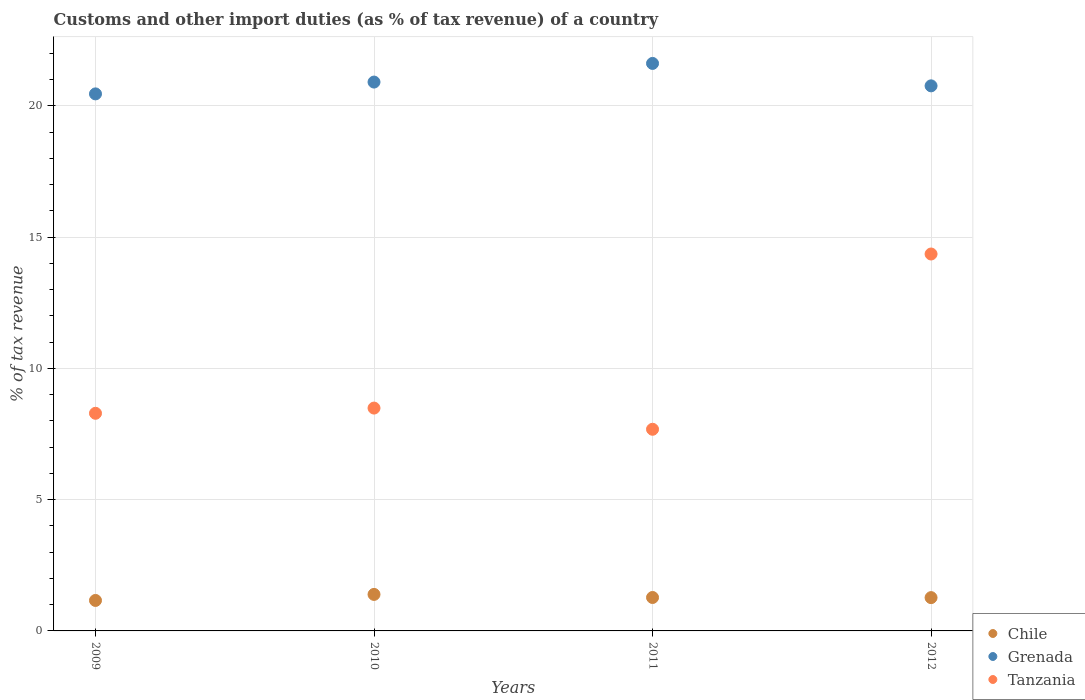Is the number of dotlines equal to the number of legend labels?
Your response must be concise. Yes. What is the percentage of tax revenue from customs in Tanzania in 2009?
Provide a succinct answer. 8.29. Across all years, what is the maximum percentage of tax revenue from customs in Grenada?
Offer a terse response. 21.61. Across all years, what is the minimum percentage of tax revenue from customs in Chile?
Offer a terse response. 1.16. In which year was the percentage of tax revenue from customs in Grenada minimum?
Keep it short and to the point. 2009. What is the total percentage of tax revenue from customs in Grenada in the graph?
Offer a very short reply. 83.73. What is the difference between the percentage of tax revenue from customs in Tanzania in 2009 and that in 2012?
Give a very brief answer. -6.07. What is the difference between the percentage of tax revenue from customs in Tanzania in 2012 and the percentage of tax revenue from customs in Chile in 2010?
Make the answer very short. 12.96. What is the average percentage of tax revenue from customs in Grenada per year?
Provide a succinct answer. 20.93. In the year 2011, what is the difference between the percentage of tax revenue from customs in Grenada and percentage of tax revenue from customs in Chile?
Provide a short and direct response. 20.34. What is the ratio of the percentage of tax revenue from customs in Chile in 2009 to that in 2012?
Offer a terse response. 0.92. Is the percentage of tax revenue from customs in Chile in 2009 less than that in 2012?
Give a very brief answer. Yes. Is the difference between the percentage of tax revenue from customs in Grenada in 2011 and 2012 greater than the difference between the percentage of tax revenue from customs in Chile in 2011 and 2012?
Offer a terse response. Yes. What is the difference between the highest and the second highest percentage of tax revenue from customs in Grenada?
Provide a short and direct response. 0.71. What is the difference between the highest and the lowest percentage of tax revenue from customs in Tanzania?
Ensure brevity in your answer.  6.67. In how many years, is the percentage of tax revenue from customs in Tanzania greater than the average percentage of tax revenue from customs in Tanzania taken over all years?
Make the answer very short. 1. Does the percentage of tax revenue from customs in Grenada monotonically increase over the years?
Your answer should be very brief. No. How many dotlines are there?
Offer a very short reply. 3. How many years are there in the graph?
Offer a very short reply. 4. What is the difference between two consecutive major ticks on the Y-axis?
Your response must be concise. 5. Where does the legend appear in the graph?
Provide a short and direct response. Bottom right. How many legend labels are there?
Make the answer very short. 3. What is the title of the graph?
Your response must be concise. Customs and other import duties (as % of tax revenue) of a country. What is the label or title of the X-axis?
Offer a terse response. Years. What is the label or title of the Y-axis?
Make the answer very short. % of tax revenue. What is the % of tax revenue in Chile in 2009?
Keep it short and to the point. 1.16. What is the % of tax revenue in Grenada in 2009?
Offer a terse response. 20.45. What is the % of tax revenue of Tanzania in 2009?
Your answer should be very brief. 8.29. What is the % of tax revenue of Chile in 2010?
Your response must be concise. 1.39. What is the % of tax revenue in Grenada in 2010?
Your answer should be compact. 20.9. What is the % of tax revenue of Tanzania in 2010?
Give a very brief answer. 8.49. What is the % of tax revenue in Chile in 2011?
Your answer should be very brief. 1.27. What is the % of tax revenue of Grenada in 2011?
Ensure brevity in your answer.  21.61. What is the % of tax revenue in Tanzania in 2011?
Ensure brevity in your answer.  7.68. What is the % of tax revenue of Chile in 2012?
Your response must be concise. 1.27. What is the % of tax revenue of Grenada in 2012?
Give a very brief answer. 20.76. What is the % of tax revenue of Tanzania in 2012?
Keep it short and to the point. 14.35. Across all years, what is the maximum % of tax revenue of Chile?
Provide a succinct answer. 1.39. Across all years, what is the maximum % of tax revenue in Grenada?
Provide a short and direct response. 21.61. Across all years, what is the maximum % of tax revenue of Tanzania?
Ensure brevity in your answer.  14.35. Across all years, what is the minimum % of tax revenue in Chile?
Offer a terse response. 1.16. Across all years, what is the minimum % of tax revenue of Grenada?
Give a very brief answer. 20.45. Across all years, what is the minimum % of tax revenue in Tanzania?
Ensure brevity in your answer.  7.68. What is the total % of tax revenue in Chile in the graph?
Provide a succinct answer. 5.09. What is the total % of tax revenue of Grenada in the graph?
Provide a short and direct response. 83.73. What is the total % of tax revenue of Tanzania in the graph?
Provide a succinct answer. 38.81. What is the difference between the % of tax revenue of Chile in 2009 and that in 2010?
Provide a succinct answer. -0.23. What is the difference between the % of tax revenue of Grenada in 2009 and that in 2010?
Provide a short and direct response. -0.45. What is the difference between the % of tax revenue of Tanzania in 2009 and that in 2010?
Keep it short and to the point. -0.2. What is the difference between the % of tax revenue in Chile in 2009 and that in 2011?
Offer a terse response. -0.11. What is the difference between the % of tax revenue in Grenada in 2009 and that in 2011?
Ensure brevity in your answer.  -1.16. What is the difference between the % of tax revenue of Tanzania in 2009 and that in 2011?
Offer a terse response. 0.61. What is the difference between the % of tax revenue of Chile in 2009 and that in 2012?
Offer a terse response. -0.11. What is the difference between the % of tax revenue in Grenada in 2009 and that in 2012?
Make the answer very short. -0.31. What is the difference between the % of tax revenue of Tanzania in 2009 and that in 2012?
Provide a succinct answer. -6.07. What is the difference between the % of tax revenue of Chile in 2010 and that in 2011?
Provide a succinct answer. 0.12. What is the difference between the % of tax revenue of Grenada in 2010 and that in 2011?
Provide a succinct answer. -0.71. What is the difference between the % of tax revenue in Tanzania in 2010 and that in 2011?
Your response must be concise. 0.81. What is the difference between the % of tax revenue of Chile in 2010 and that in 2012?
Your answer should be compact. 0.12. What is the difference between the % of tax revenue of Grenada in 2010 and that in 2012?
Make the answer very short. 0.14. What is the difference between the % of tax revenue of Tanzania in 2010 and that in 2012?
Offer a terse response. -5.87. What is the difference between the % of tax revenue in Chile in 2011 and that in 2012?
Give a very brief answer. 0. What is the difference between the % of tax revenue of Grenada in 2011 and that in 2012?
Give a very brief answer. 0.85. What is the difference between the % of tax revenue of Tanzania in 2011 and that in 2012?
Your answer should be compact. -6.67. What is the difference between the % of tax revenue in Chile in 2009 and the % of tax revenue in Grenada in 2010?
Ensure brevity in your answer.  -19.74. What is the difference between the % of tax revenue of Chile in 2009 and the % of tax revenue of Tanzania in 2010?
Offer a terse response. -7.33. What is the difference between the % of tax revenue in Grenada in 2009 and the % of tax revenue in Tanzania in 2010?
Offer a very short reply. 11.97. What is the difference between the % of tax revenue of Chile in 2009 and the % of tax revenue of Grenada in 2011?
Your answer should be very brief. -20.45. What is the difference between the % of tax revenue in Chile in 2009 and the % of tax revenue in Tanzania in 2011?
Your answer should be very brief. -6.52. What is the difference between the % of tax revenue in Grenada in 2009 and the % of tax revenue in Tanzania in 2011?
Give a very brief answer. 12.77. What is the difference between the % of tax revenue in Chile in 2009 and the % of tax revenue in Grenada in 2012?
Give a very brief answer. -19.6. What is the difference between the % of tax revenue in Chile in 2009 and the % of tax revenue in Tanzania in 2012?
Make the answer very short. -13.19. What is the difference between the % of tax revenue in Grenada in 2009 and the % of tax revenue in Tanzania in 2012?
Offer a very short reply. 6.1. What is the difference between the % of tax revenue of Chile in 2010 and the % of tax revenue of Grenada in 2011?
Your response must be concise. -20.22. What is the difference between the % of tax revenue in Chile in 2010 and the % of tax revenue in Tanzania in 2011?
Offer a very short reply. -6.29. What is the difference between the % of tax revenue of Grenada in 2010 and the % of tax revenue of Tanzania in 2011?
Keep it short and to the point. 13.22. What is the difference between the % of tax revenue in Chile in 2010 and the % of tax revenue in Grenada in 2012?
Your answer should be compact. -19.37. What is the difference between the % of tax revenue in Chile in 2010 and the % of tax revenue in Tanzania in 2012?
Offer a very short reply. -12.96. What is the difference between the % of tax revenue in Grenada in 2010 and the % of tax revenue in Tanzania in 2012?
Your response must be concise. 6.55. What is the difference between the % of tax revenue of Chile in 2011 and the % of tax revenue of Grenada in 2012?
Offer a very short reply. -19.49. What is the difference between the % of tax revenue in Chile in 2011 and the % of tax revenue in Tanzania in 2012?
Offer a very short reply. -13.08. What is the difference between the % of tax revenue in Grenada in 2011 and the % of tax revenue in Tanzania in 2012?
Your answer should be very brief. 7.26. What is the average % of tax revenue of Chile per year?
Offer a very short reply. 1.27. What is the average % of tax revenue of Grenada per year?
Your answer should be compact. 20.93. What is the average % of tax revenue of Tanzania per year?
Your answer should be very brief. 9.7. In the year 2009, what is the difference between the % of tax revenue of Chile and % of tax revenue of Grenada?
Your answer should be compact. -19.29. In the year 2009, what is the difference between the % of tax revenue in Chile and % of tax revenue in Tanzania?
Provide a succinct answer. -7.13. In the year 2009, what is the difference between the % of tax revenue in Grenada and % of tax revenue in Tanzania?
Your response must be concise. 12.16. In the year 2010, what is the difference between the % of tax revenue in Chile and % of tax revenue in Grenada?
Provide a short and direct response. -19.51. In the year 2010, what is the difference between the % of tax revenue of Chile and % of tax revenue of Tanzania?
Ensure brevity in your answer.  -7.1. In the year 2010, what is the difference between the % of tax revenue of Grenada and % of tax revenue of Tanzania?
Offer a very short reply. 12.42. In the year 2011, what is the difference between the % of tax revenue in Chile and % of tax revenue in Grenada?
Your response must be concise. -20.34. In the year 2011, what is the difference between the % of tax revenue of Chile and % of tax revenue of Tanzania?
Make the answer very short. -6.41. In the year 2011, what is the difference between the % of tax revenue in Grenada and % of tax revenue in Tanzania?
Make the answer very short. 13.93. In the year 2012, what is the difference between the % of tax revenue of Chile and % of tax revenue of Grenada?
Make the answer very short. -19.49. In the year 2012, what is the difference between the % of tax revenue of Chile and % of tax revenue of Tanzania?
Make the answer very short. -13.09. In the year 2012, what is the difference between the % of tax revenue of Grenada and % of tax revenue of Tanzania?
Make the answer very short. 6.4. What is the ratio of the % of tax revenue in Chile in 2009 to that in 2010?
Your response must be concise. 0.83. What is the ratio of the % of tax revenue in Grenada in 2009 to that in 2010?
Keep it short and to the point. 0.98. What is the ratio of the % of tax revenue of Tanzania in 2009 to that in 2010?
Keep it short and to the point. 0.98. What is the ratio of the % of tax revenue in Chile in 2009 to that in 2011?
Make the answer very short. 0.91. What is the ratio of the % of tax revenue of Grenada in 2009 to that in 2011?
Provide a short and direct response. 0.95. What is the ratio of the % of tax revenue in Tanzania in 2009 to that in 2011?
Provide a short and direct response. 1.08. What is the ratio of the % of tax revenue of Chile in 2009 to that in 2012?
Your response must be concise. 0.92. What is the ratio of the % of tax revenue of Tanzania in 2009 to that in 2012?
Provide a short and direct response. 0.58. What is the ratio of the % of tax revenue of Chile in 2010 to that in 2011?
Your answer should be compact. 1.09. What is the ratio of the % of tax revenue of Grenada in 2010 to that in 2011?
Your response must be concise. 0.97. What is the ratio of the % of tax revenue of Tanzania in 2010 to that in 2011?
Ensure brevity in your answer.  1.11. What is the ratio of the % of tax revenue of Chile in 2010 to that in 2012?
Ensure brevity in your answer.  1.1. What is the ratio of the % of tax revenue of Grenada in 2010 to that in 2012?
Your answer should be compact. 1.01. What is the ratio of the % of tax revenue in Tanzania in 2010 to that in 2012?
Offer a very short reply. 0.59. What is the ratio of the % of tax revenue in Grenada in 2011 to that in 2012?
Provide a short and direct response. 1.04. What is the ratio of the % of tax revenue in Tanzania in 2011 to that in 2012?
Keep it short and to the point. 0.54. What is the difference between the highest and the second highest % of tax revenue of Chile?
Your response must be concise. 0.12. What is the difference between the highest and the second highest % of tax revenue in Grenada?
Keep it short and to the point. 0.71. What is the difference between the highest and the second highest % of tax revenue in Tanzania?
Make the answer very short. 5.87. What is the difference between the highest and the lowest % of tax revenue of Chile?
Keep it short and to the point. 0.23. What is the difference between the highest and the lowest % of tax revenue in Grenada?
Offer a terse response. 1.16. What is the difference between the highest and the lowest % of tax revenue of Tanzania?
Keep it short and to the point. 6.67. 